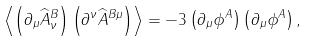Convert formula to latex. <formula><loc_0><loc_0><loc_500><loc_500>\left \langle \left ( \partial _ { \mu } \widehat { A } ^ { B } _ { \nu } \right ) \left ( \partial ^ { \nu } \widehat { A } ^ { B \mu } \right ) \right \rangle = - 3 \left ( \partial _ { \mu } \phi ^ { A } \right ) \left ( \partial _ { \mu } \phi ^ { A } \right ) ,</formula> 